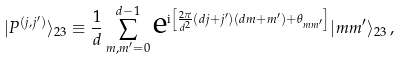Convert formula to latex. <formula><loc_0><loc_0><loc_500><loc_500>| P ^ { ( j , j ^ { \prime } ) } \rangle _ { 2 3 } \equiv \frac { 1 } { d } \sum _ { m , m ^ { \prime } = 0 } ^ { d - 1 } \text {e} ^ { \text {i} \left [ \frac { 2 \pi } { d ^ { 2 } } ( d j + j ^ { \prime } ) ( d m + m ^ { \prime } ) + \theta _ { m m ^ { \prime } } \right ] } | m m ^ { \prime } \rangle _ { 2 3 } \, ,</formula> 